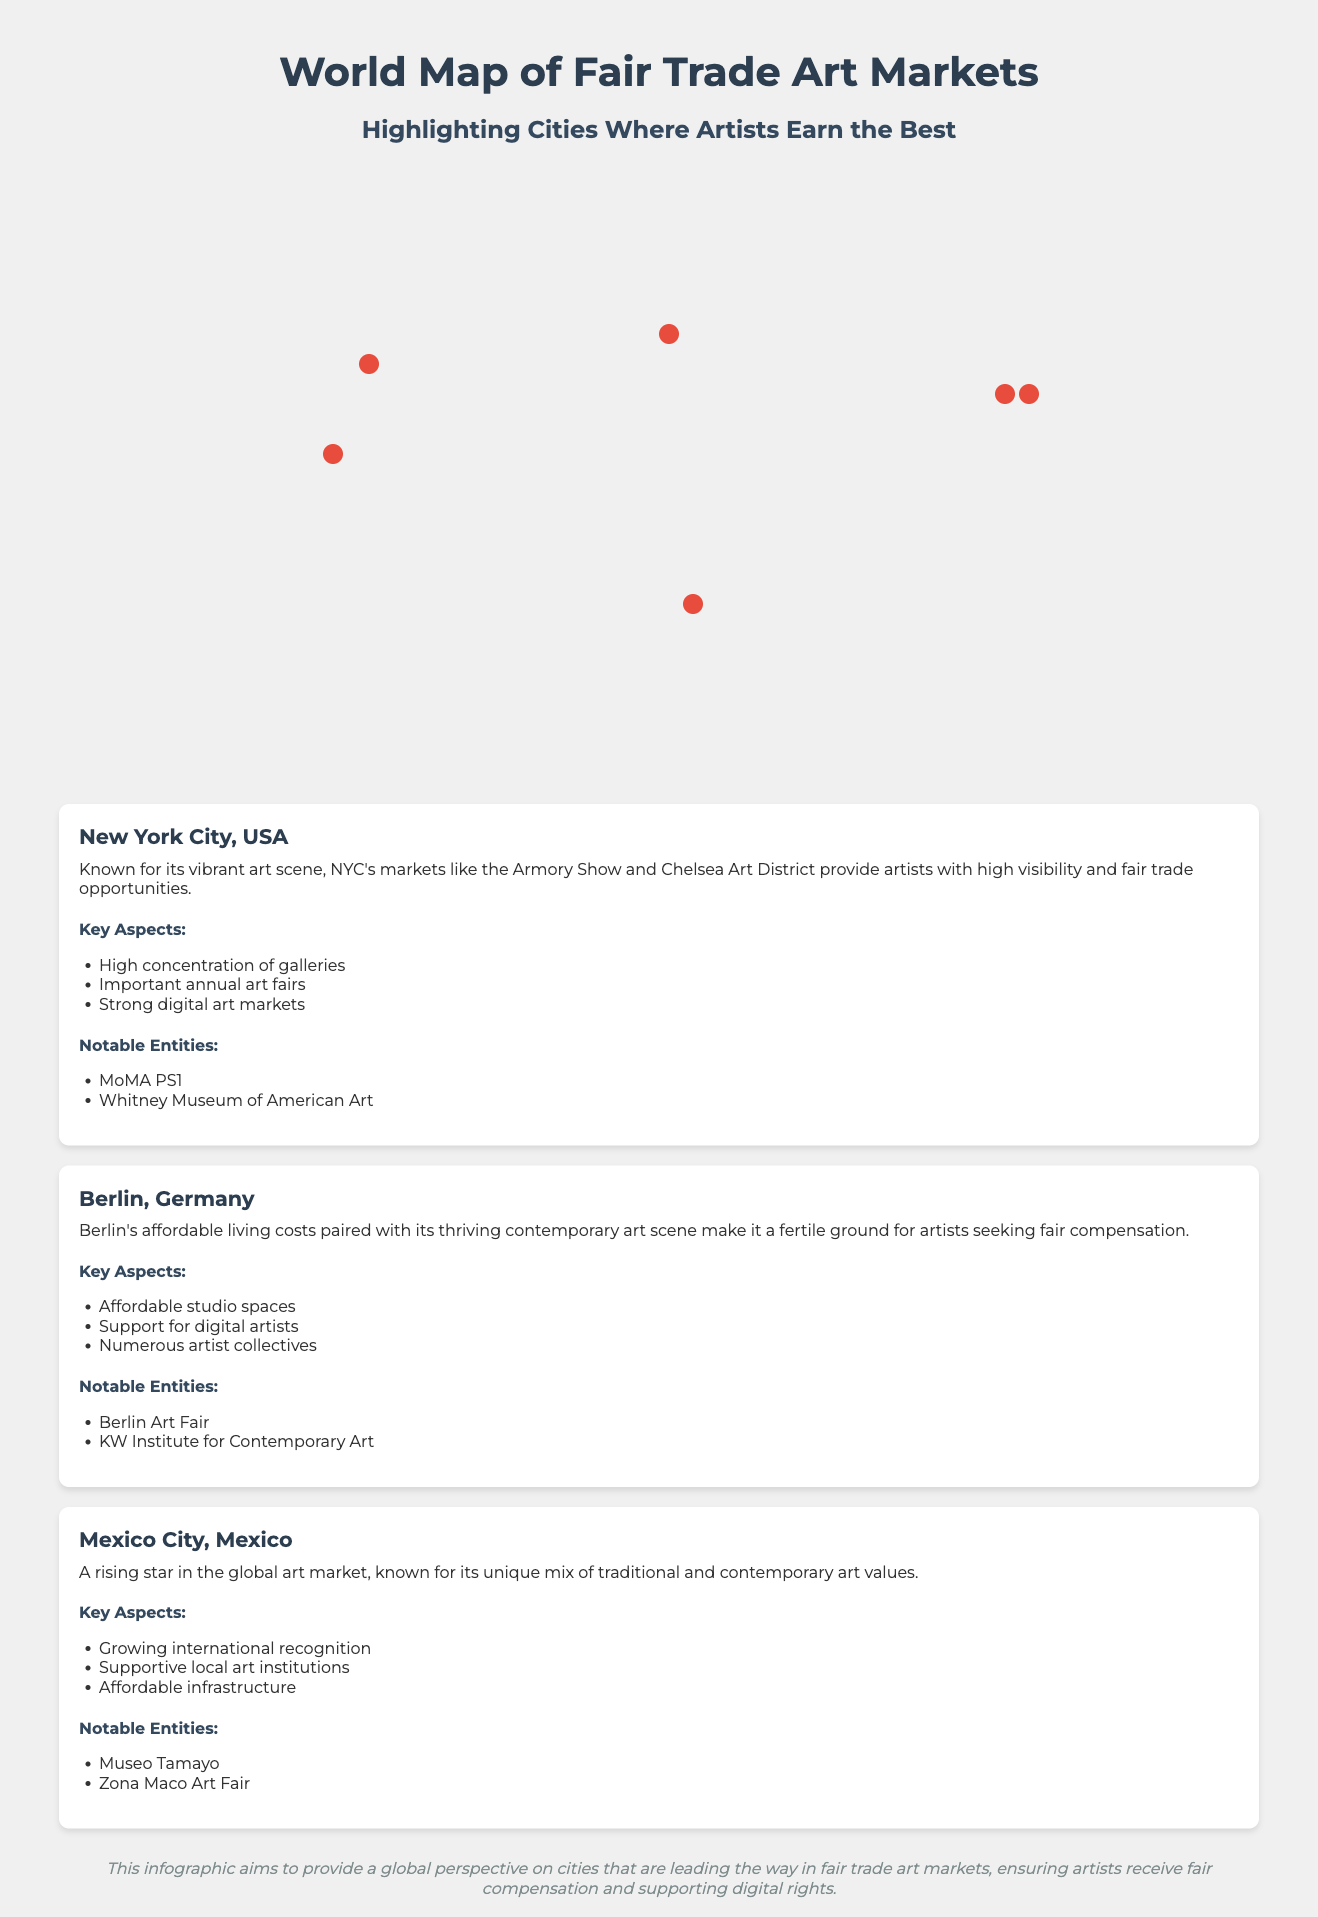What city in the USA is highlighted? The document highlights New York City, USA as the city in the USA with fair trade art markets.
Answer: New York City, USA Which city has a notable entity named Museo Tamayo? The notable entity Museo Tamayo is associated with Mexico City, Mexico, mentioned in the document.
Answer: Mexico City, Mexico What is one key aspect of Berlin's art market? The document states that affordable studio spaces are one key aspect of Berlin's art market.
Answer: Affordable studio spaces How many cities are marked on the world map? The map showcases a total of six cities where artists earn well, as indicated by the city markers.
Answer: Six cities Which city is known for its strong digital art markets? New York City, USA is noted for having strong digital art markets in the document.
Answer: New York City, USA What key aspect is mentioned for Mexico City? The document mentions growing international recognition as a key aspect for Mexico City.
Answer: Growing international recognition Which two notable entities are associated with New York City? The document lists MoMA PS1 and Whitney Museum of American Art as notable entities in New York City.
Answer: MoMA PS1, Whitney Museum of American Art What type of art scene does Berlin offer? The document describes Berlin as having a thriving contemporary art scene.
Answer: Thriving contemporary art scene What is a notable art fair in Mexico City? Zona Maco Art Fair is highlighted as a notable art fair in Mexico City.
Answer: Zona Maco Art Fair 